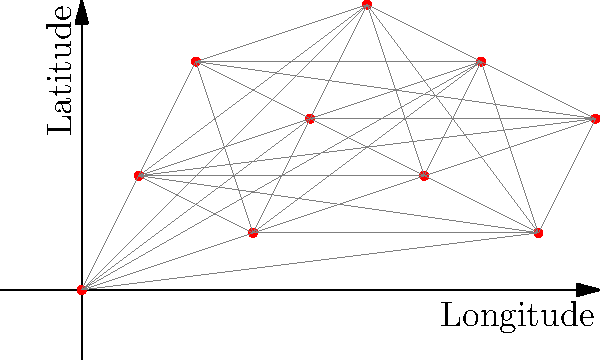Analyze the spatial distribution of archaeological sites in Egypt represented by the red dots in the graph. Which of the following point pattern analysis techniques would be most appropriate to determine if the sites exhibit clustering, and why?

A) Nearest Neighbor Analysis
B) Ripley's K-function
C) Quadrat Analysis
D) Kernel Density Estimation To analyze the spatial distribution of archaeological sites in Egypt, we need to consider the following steps:

1. Observe the pattern: The graph shows a scatter of points representing archaeological sites across a 2D space (longitude and latitude).

2. Consider the scale: The distribution covers a relatively large area, suggesting a regional-scale analysis.

3. Evaluate the options:

   A) Nearest Neighbor Analysis: This method compares the observed average distance between nearest neighbors to the expected distance in a random distribution. It's useful for determining overall clustering or dispersion but doesn't account for scale-dependent patterns.

   B) Ripley's K-function: This technique analyzes spatial patterns at multiple distances, making it ideal for detecting clustering or dispersion at various scales. It's particularly useful for identifying complex patterns that may vary with distance.

   C) Quadrat Analysis: This method divides the study area into equal-sized quadrats and counts the number of points in each. It's better suited for uniform distributions or when the scale of analysis is predetermined.

   D) Kernel Density Estimation: This creates a smooth density surface but doesn't directly test for clustering or dispersion.

4. Choose the most appropriate method: Given the apparent complexity of the distribution and the importance of scale in archaeological site patterns, Ripley's K-function (option B) is the most suitable technique.

5. Justification: Ripley's K-function can detect clustering or dispersion at multiple scales, which is crucial for understanding the spatial relationships between archaeological sites. It can reveal patterns that might be influenced by various factors such as ancient settlement hierarchies, trade routes, or environmental conditions.
Answer: B) Ripley's K-function 